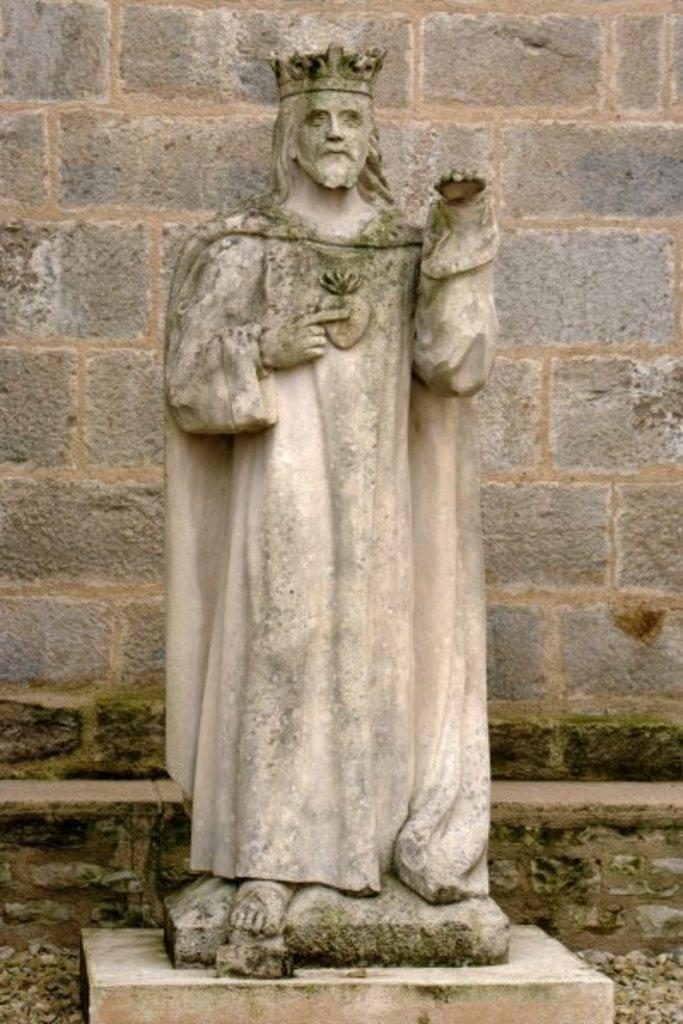What is the main subject in the image? There is a statue in the image. Can you describe the statue's location? The statue is in front of a wall. How many dogs are following the trail near the statue in the image? There is no trail or dogs present in the image; it only features a statue in front of a wall. 